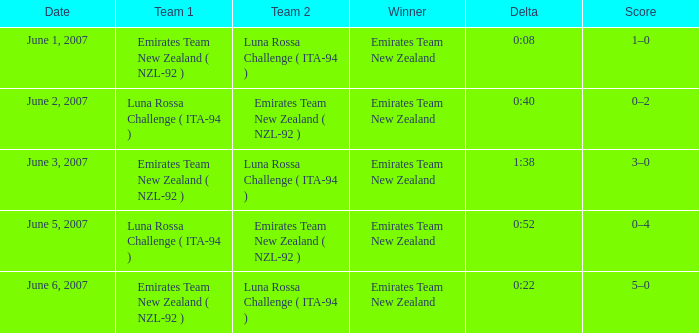Who is the Winner on June 2, 2007? Emirates Team New Zealand. 